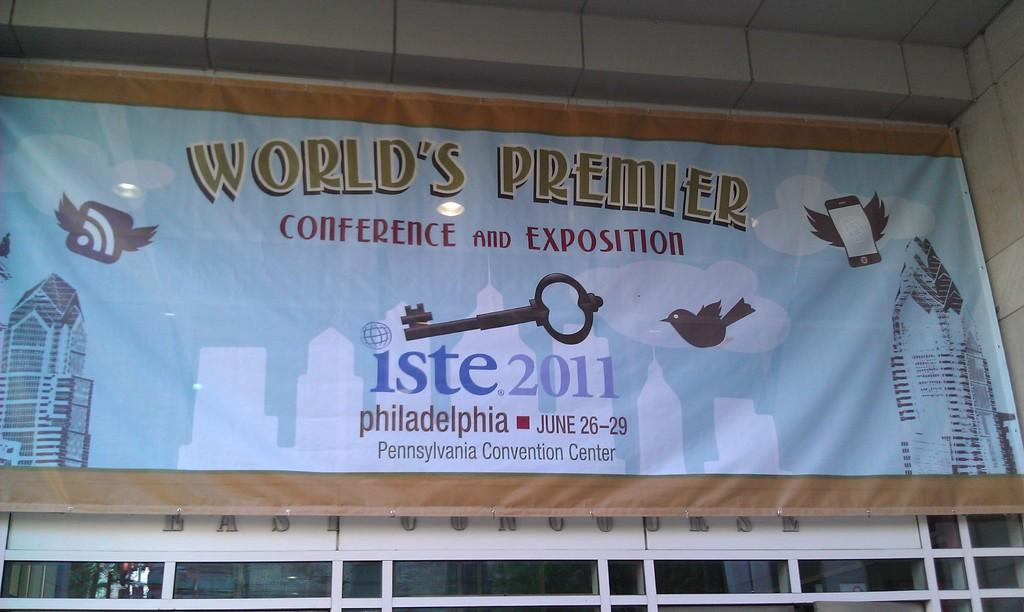<image>
Give a short and clear explanation of the subsequent image. A white billboard sign with wooden trims that says "world's premier" for iste.2011. 